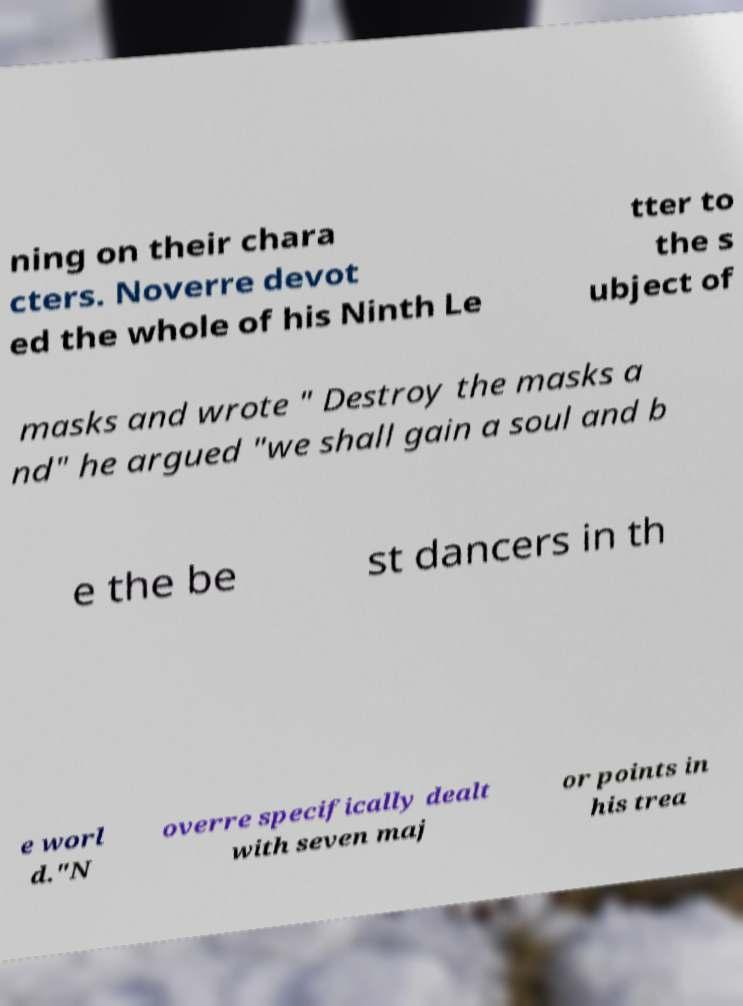Can you read and provide the text displayed in the image?This photo seems to have some interesting text. Can you extract and type it out for me? ning on their chara cters. Noverre devot ed the whole of his Ninth Le tter to the s ubject of masks and wrote " Destroy the masks a nd" he argued "we shall gain a soul and b e the be st dancers in th e worl d."N overre specifically dealt with seven maj or points in his trea 